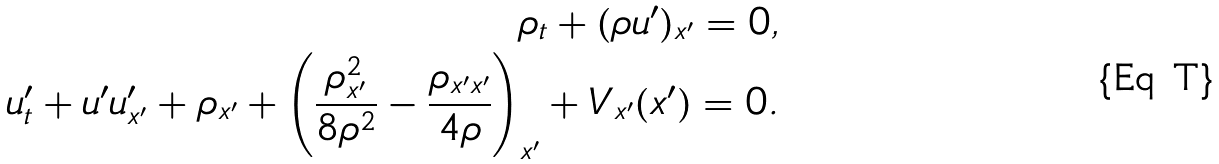<formula> <loc_0><loc_0><loc_500><loc_500>\rho _ { t } + ( \rho u ^ { \prime } ) _ { x ^ { \prime } } = 0 , \\ u ^ { \prime } _ { t } + u ^ { \prime } u ^ { \prime } _ { x ^ { \prime } } + \rho _ { x ^ { \prime } } + \left ( \frac { \rho _ { x ^ { \prime } } ^ { 2 } } { 8 \rho ^ { 2 } } - \frac { \rho _ { x ^ { \prime } x ^ { \prime } } } { 4 \rho } \right ) _ { x ^ { \prime } } + V _ { x ^ { \prime } } ( x ^ { \prime } ) = 0 .</formula> 